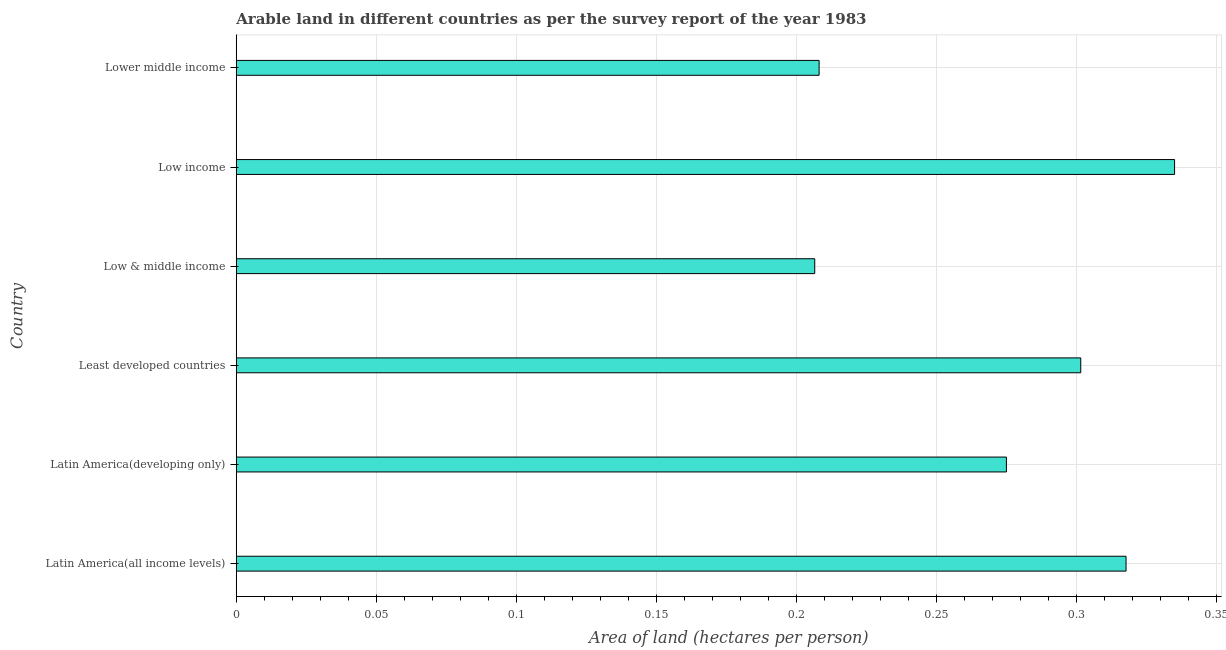Does the graph contain any zero values?
Provide a succinct answer. No. What is the title of the graph?
Make the answer very short. Arable land in different countries as per the survey report of the year 1983. What is the label or title of the X-axis?
Provide a short and direct response. Area of land (hectares per person). What is the label or title of the Y-axis?
Your answer should be very brief. Country. What is the area of arable land in Lower middle income?
Your response must be concise. 0.21. Across all countries, what is the maximum area of arable land?
Offer a terse response. 0.33. Across all countries, what is the minimum area of arable land?
Make the answer very short. 0.21. In which country was the area of arable land maximum?
Offer a terse response. Low income. In which country was the area of arable land minimum?
Provide a short and direct response. Low & middle income. What is the sum of the area of arable land?
Offer a terse response. 1.64. What is the difference between the area of arable land in Latin America(all income levels) and Least developed countries?
Provide a short and direct response. 0.02. What is the average area of arable land per country?
Offer a terse response. 0.27. What is the median area of arable land?
Your answer should be very brief. 0.29. What is the ratio of the area of arable land in Latin America(developing only) to that in Lower middle income?
Provide a short and direct response. 1.32. Is the area of arable land in Latin America(developing only) less than that in Least developed countries?
Provide a short and direct response. Yes. What is the difference between the highest and the second highest area of arable land?
Your response must be concise. 0.02. What is the difference between the highest and the lowest area of arable land?
Give a very brief answer. 0.13. How many bars are there?
Your response must be concise. 6. Are all the bars in the graph horizontal?
Make the answer very short. Yes. How many countries are there in the graph?
Your answer should be very brief. 6. What is the Area of land (hectares per person) of Latin America(all income levels)?
Offer a very short reply. 0.32. What is the Area of land (hectares per person) of Latin America(developing only)?
Provide a succinct answer. 0.27. What is the Area of land (hectares per person) in Least developed countries?
Provide a succinct answer. 0.3. What is the Area of land (hectares per person) in Low & middle income?
Offer a terse response. 0.21. What is the Area of land (hectares per person) of Low income?
Your response must be concise. 0.33. What is the Area of land (hectares per person) of Lower middle income?
Your answer should be compact. 0.21. What is the difference between the Area of land (hectares per person) in Latin America(all income levels) and Latin America(developing only)?
Keep it short and to the point. 0.04. What is the difference between the Area of land (hectares per person) in Latin America(all income levels) and Least developed countries?
Your response must be concise. 0.02. What is the difference between the Area of land (hectares per person) in Latin America(all income levels) and Low income?
Offer a very short reply. -0.02. What is the difference between the Area of land (hectares per person) in Latin America(all income levels) and Lower middle income?
Provide a short and direct response. 0.11. What is the difference between the Area of land (hectares per person) in Latin America(developing only) and Least developed countries?
Keep it short and to the point. -0.03. What is the difference between the Area of land (hectares per person) in Latin America(developing only) and Low & middle income?
Give a very brief answer. 0.07. What is the difference between the Area of land (hectares per person) in Latin America(developing only) and Low income?
Provide a succinct answer. -0.06. What is the difference between the Area of land (hectares per person) in Latin America(developing only) and Lower middle income?
Provide a short and direct response. 0.07. What is the difference between the Area of land (hectares per person) in Least developed countries and Low & middle income?
Your answer should be compact. 0.09. What is the difference between the Area of land (hectares per person) in Least developed countries and Low income?
Provide a short and direct response. -0.03. What is the difference between the Area of land (hectares per person) in Least developed countries and Lower middle income?
Ensure brevity in your answer.  0.09. What is the difference between the Area of land (hectares per person) in Low & middle income and Low income?
Offer a very short reply. -0.13. What is the difference between the Area of land (hectares per person) in Low & middle income and Lower middle income?
Keep it short and to the point. -0. What is the difference between the Area of land (hectares per person) in Low income and Lower middle income?
Provide a succinct answer. 0.13. What is the ratio of the Area of land (hectares per person) in Latin America(all income levels) to that in Latin America(developing only)?
Make the answer very short. 1.16. What is the ratio of the Area of land (hectares per person) in Latin America(all income levels) to that in Least developed countries?
Make the answer very short. 1.05. What is the ratio of the Area of land (hectares per person) in Latin America(all income levels) to that in Low & middle income?
Your response must be concise. 1.54. What is the ratio of the Area of land (hectares per person) in Latin America(all income levels) to that in Low income?
Your response must be concise. 0.95. What is the ratio of the Area of land (hectares per person) in Latin America(all income levels) to that in Lower middle income?
Your answer should be very brief. 1.53. What is the ratio of the Area of land (hectares per person) in Latin America(developing only) to that in Least developed countries?
Make the answer very short. 0.91. What is the ratio of the Area of land (hectares per person) in Latin America(developing only) to that in Low & middle income?
Provide a short and direct response. 1.33. What is the ratio of the Area of land (hectares per person) in Latin America(developing only) to that in Low income?
Give a very brief answer. 0.82. What is the ratio of the Area of land (hectares per person) in Latin America(developing only) to that in Lower middle income?
Your answer should be compact. 1.32. What is the ratio of the Area of land (hectares per person) in Least developed countries to that in Low & middle income?
Make the answer very short. 1.46. What is the ratio of the Area of land (hectares per person) in Least developed countries to that in Low income?
Your response must be concise. 0.9. What is the ratio of the Area of land (hectares per person) in Least developed countries to that in Lower middle income?
Offer a very short reply. 1.45. What is the ratio of the Area of land (hectares per person) in Low & middle income to that in Low income?
Provide a short and direct response. 0.62. What is the ratio of the Area of land (hectares per person) in Low & middle income to that in Lower middle income?
Offer a terse response. 0.99. What is the ratio of the Area of land (hectares per person) in Low income to that in Lower middle income?
Your response must be concise. 1.61. 